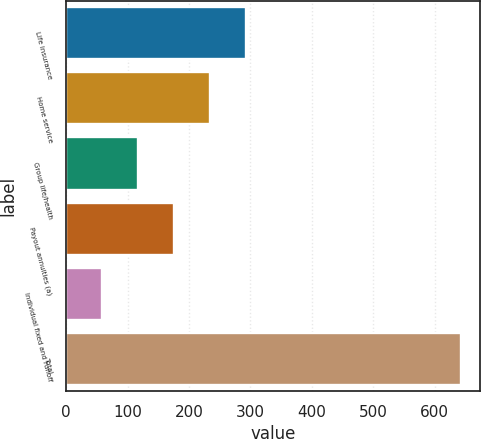<chart> <loc_0><loc_0><loc_500><loc_500><bar_chart><fcel>Life insurance<fcel>Home service<fcel>Group life/health<fcel>Payout annuities (a)<fcel>Individual fixed and runoff<fcel>Total<nl><fcel>292.2<fcel>233.9<fcel>117.3<fcel>175.6<fcel>59<fcel>642<nl></chart> 